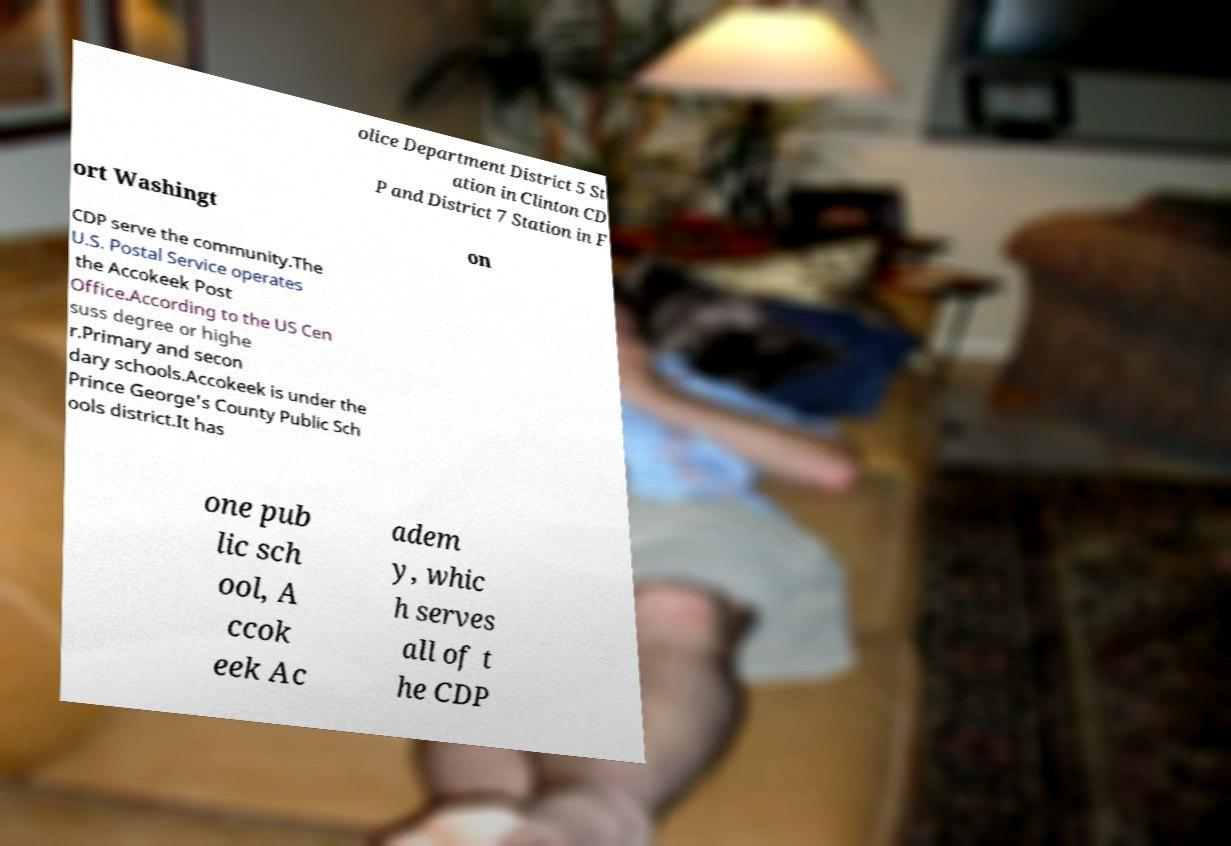Can you accurately transcribe the text from the provided image for me? olice Department District 5 St ation in Clinton CD P and District 7 Station in F ort Washingt on CDP serve the community.The U.S. Postal Service operates the Accokeek Post Office.According to the US Cen suss degree or highe r.Primary and secon dary schools.Accokeek is under the Prince George's County Public Sch ools district.It has one pub lic sch ool, A ccok eek Ac adem y, whic h serves all of t he CDP 